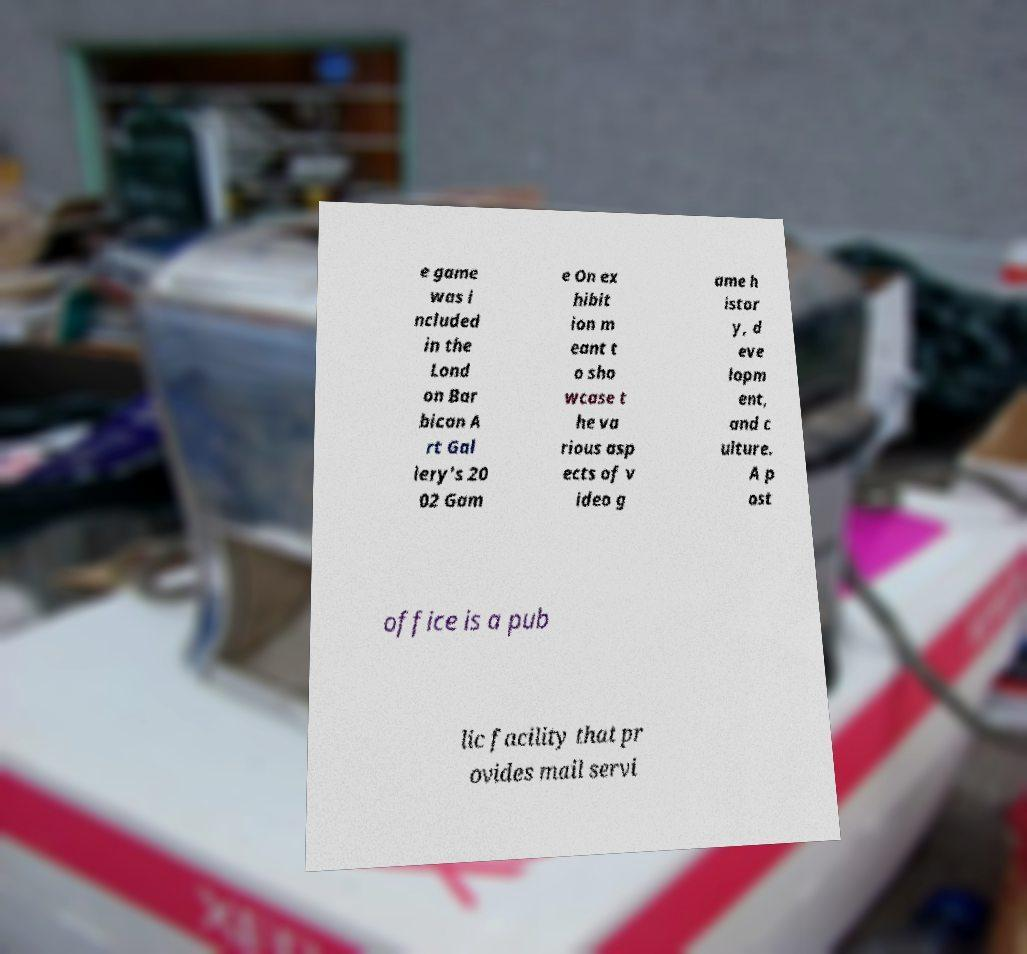Can you read and provide the text displayed in the image?This photo seems to have some interesting text. Can you extract and type it out for me? e game was i ncluded in the Lond on Bar bican A rt Gal lery's 20 02 Gam e On ex hibit ion m eant t o sho wcase t he va rious asp ects of v ideo g ame h istor y, d eve lopm ent, and c ulture. A p ost office is a pub lic facility that pr ovides mail servi 